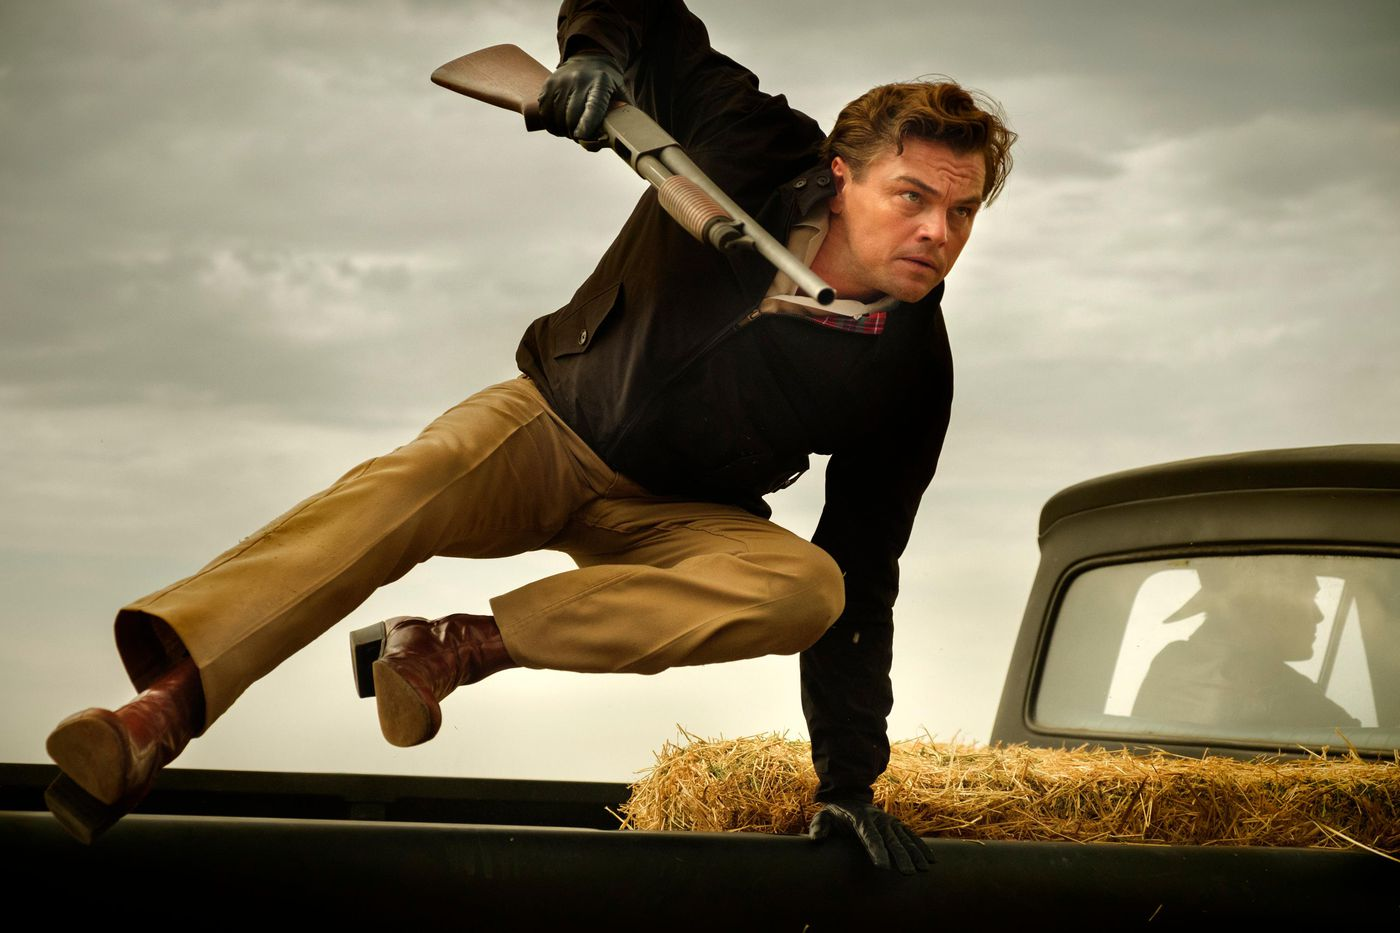Write a detailed description of the given image. In the image, a man is captured in a dynamic pose as he leaps over a black car, with hay scattered on its hood. The action is accentuated by his intense expression and the shotgun in his hand, suggesting a scene from an action or adventure movie. He wears a black jacket, a plaid shirt, and tan pants, which contrast strikingly against the rural backdrop. The cloudy sky and the man's serious demeanor indicate a scene charged with suspense and drama. 